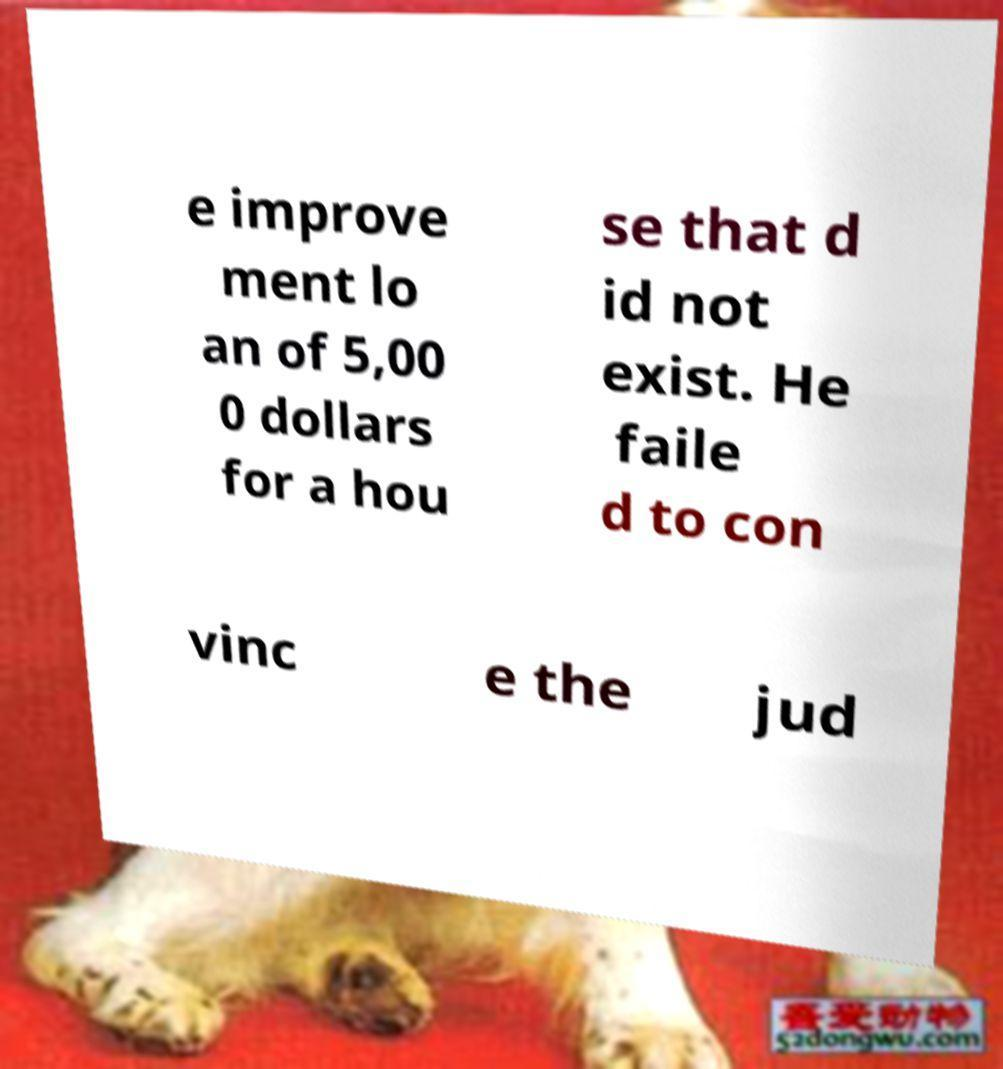What messages or text are displayed in this image? I need them in a readable, typed format. e improve ment lo an of 5,00 0 dollars for a hou se that d id not exist. He faile d to con vinc e the jud 